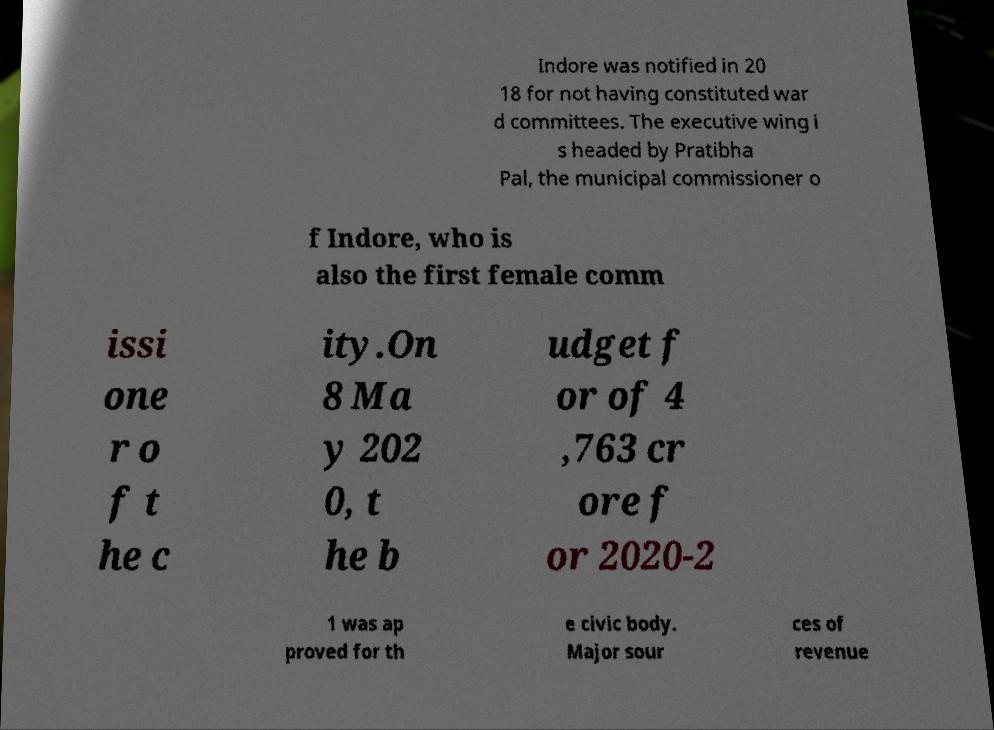Please identify and transcribe the text found in this image. Indore was notified in 20 18 for not having constituted war d committees. The executive wing i s headed by Pratibha Pal, the municipal commissioner o f Indore, who is also the first female comm issi one r o f t he c ity.On 8 Ma y 202 0, t he b udget f or of 4 ,763 cr ore f or 2020-2 1 was ap proved for th e civic body. Major sour ces of revenue 